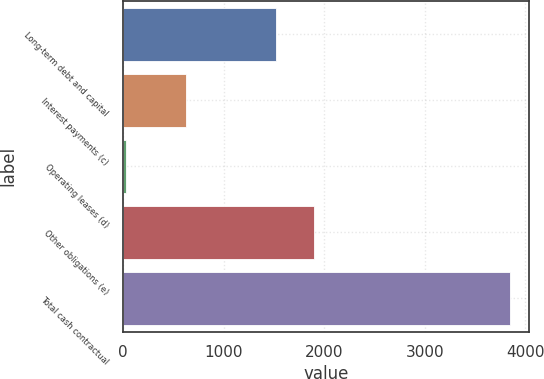Convert chart to OTSL. <chart><loc_0><loc_0><loc_500><loc_500><bar_chart><fcel>Long-term debt and capital<fcel>Interest payments (c)<fcel>Operating leases (d)<fcel>Other obligations (e)<fcel>Total cash contractual<nl><fcel>1521<fcel>626<fcel>25<fcel>1903.3<fcel>3848<nl></chart> 